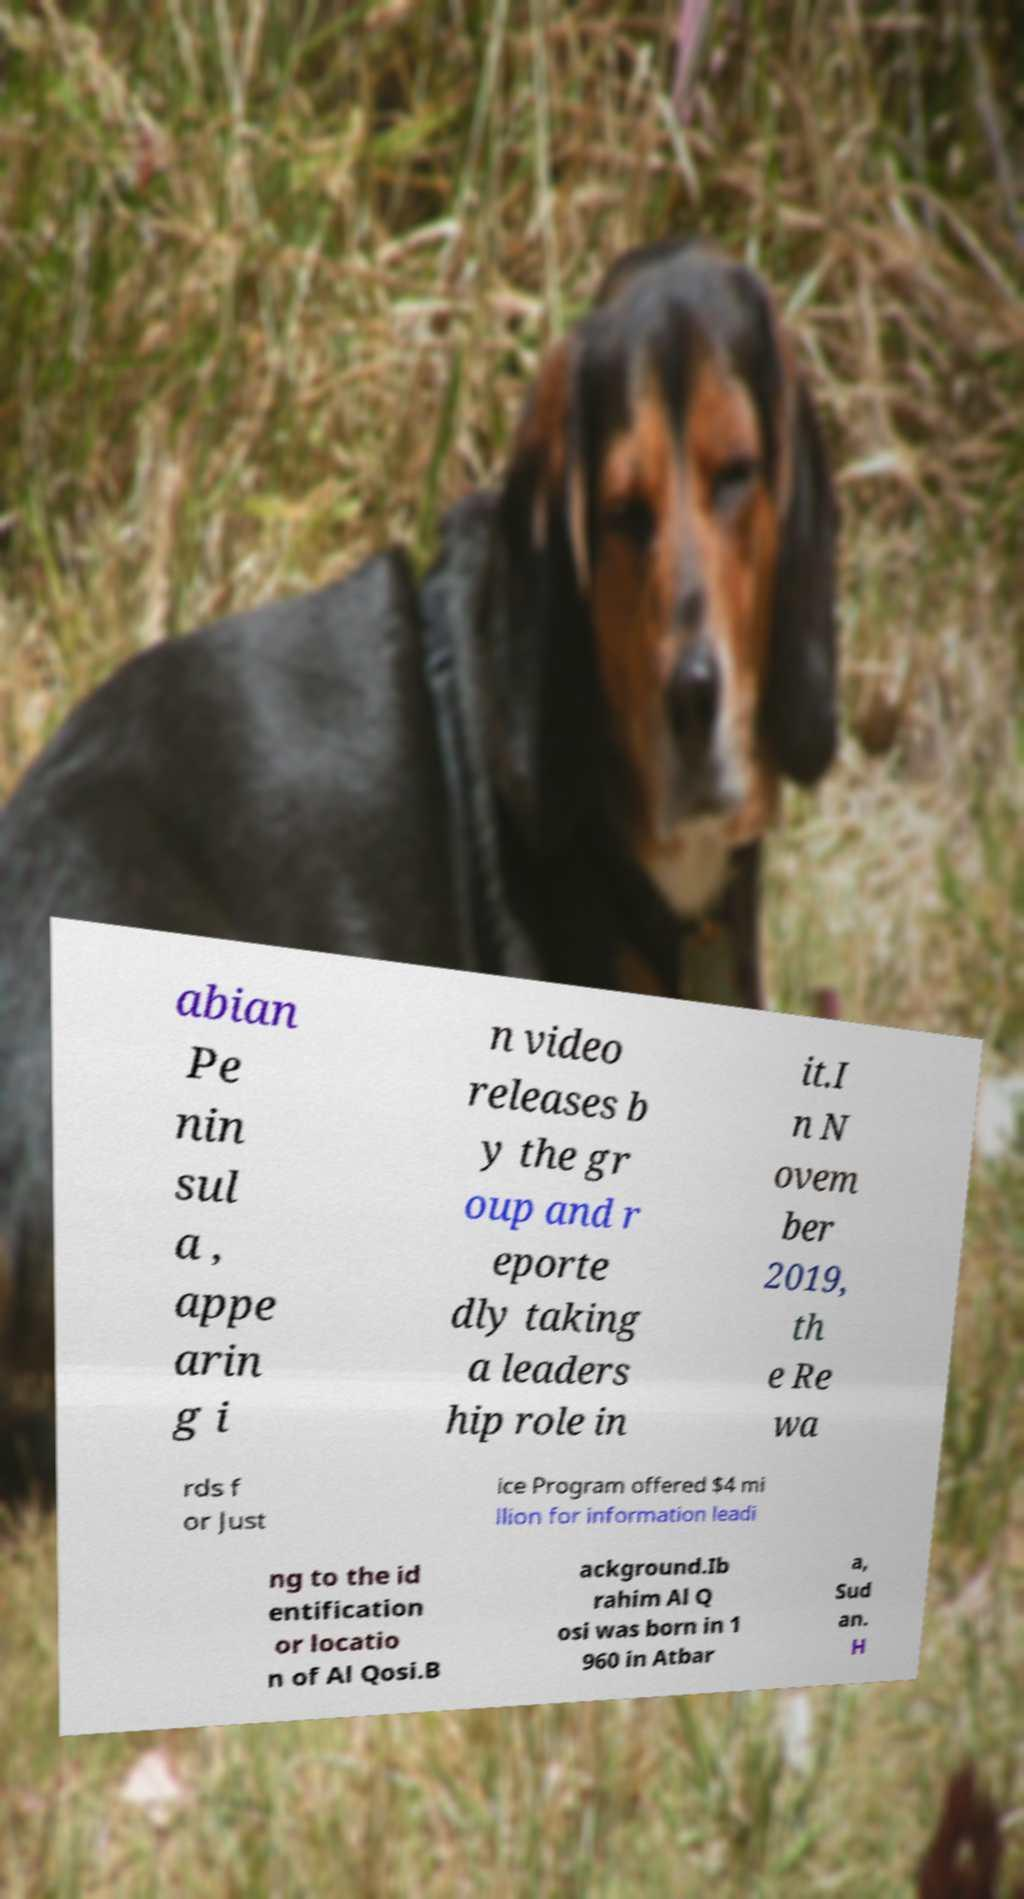Please read and relay the text visible in this image. What does it say? abian Pe nin sul a , appe arin g i n video releases b y the gr oup and r eporte dly taking a leaders hip role in it.I n N ovem ber 2019, th e Re wa rds f or Just ice Program offered $4 mi llion for information leadi ng to the id entification or locatio n of Al Qosi.B ackground.Ib rahim Al Q osi was born in 1 960 in Atbar a, Sud an. H 